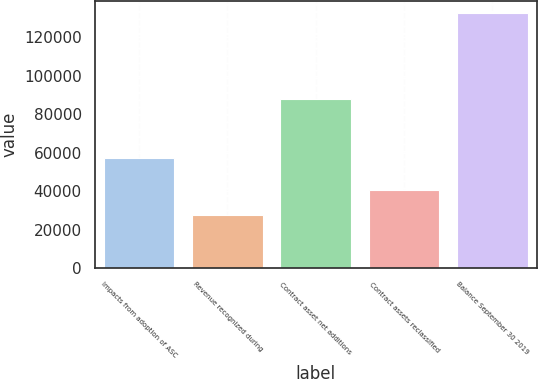<chart> <loc_0><loc_0><loc_500><loc_500><bar_chart><fcel>Impacts from adoption of ASC<fcel>Revenue recognized during<fcel>Contract asset net additions<fcel>Contract assets reclassified<fcel>Balance September 30 2019<nl><fcel>57499<fcel>27459<fcel>88068<fcel>40534<fcel>132492<nl></chart> 